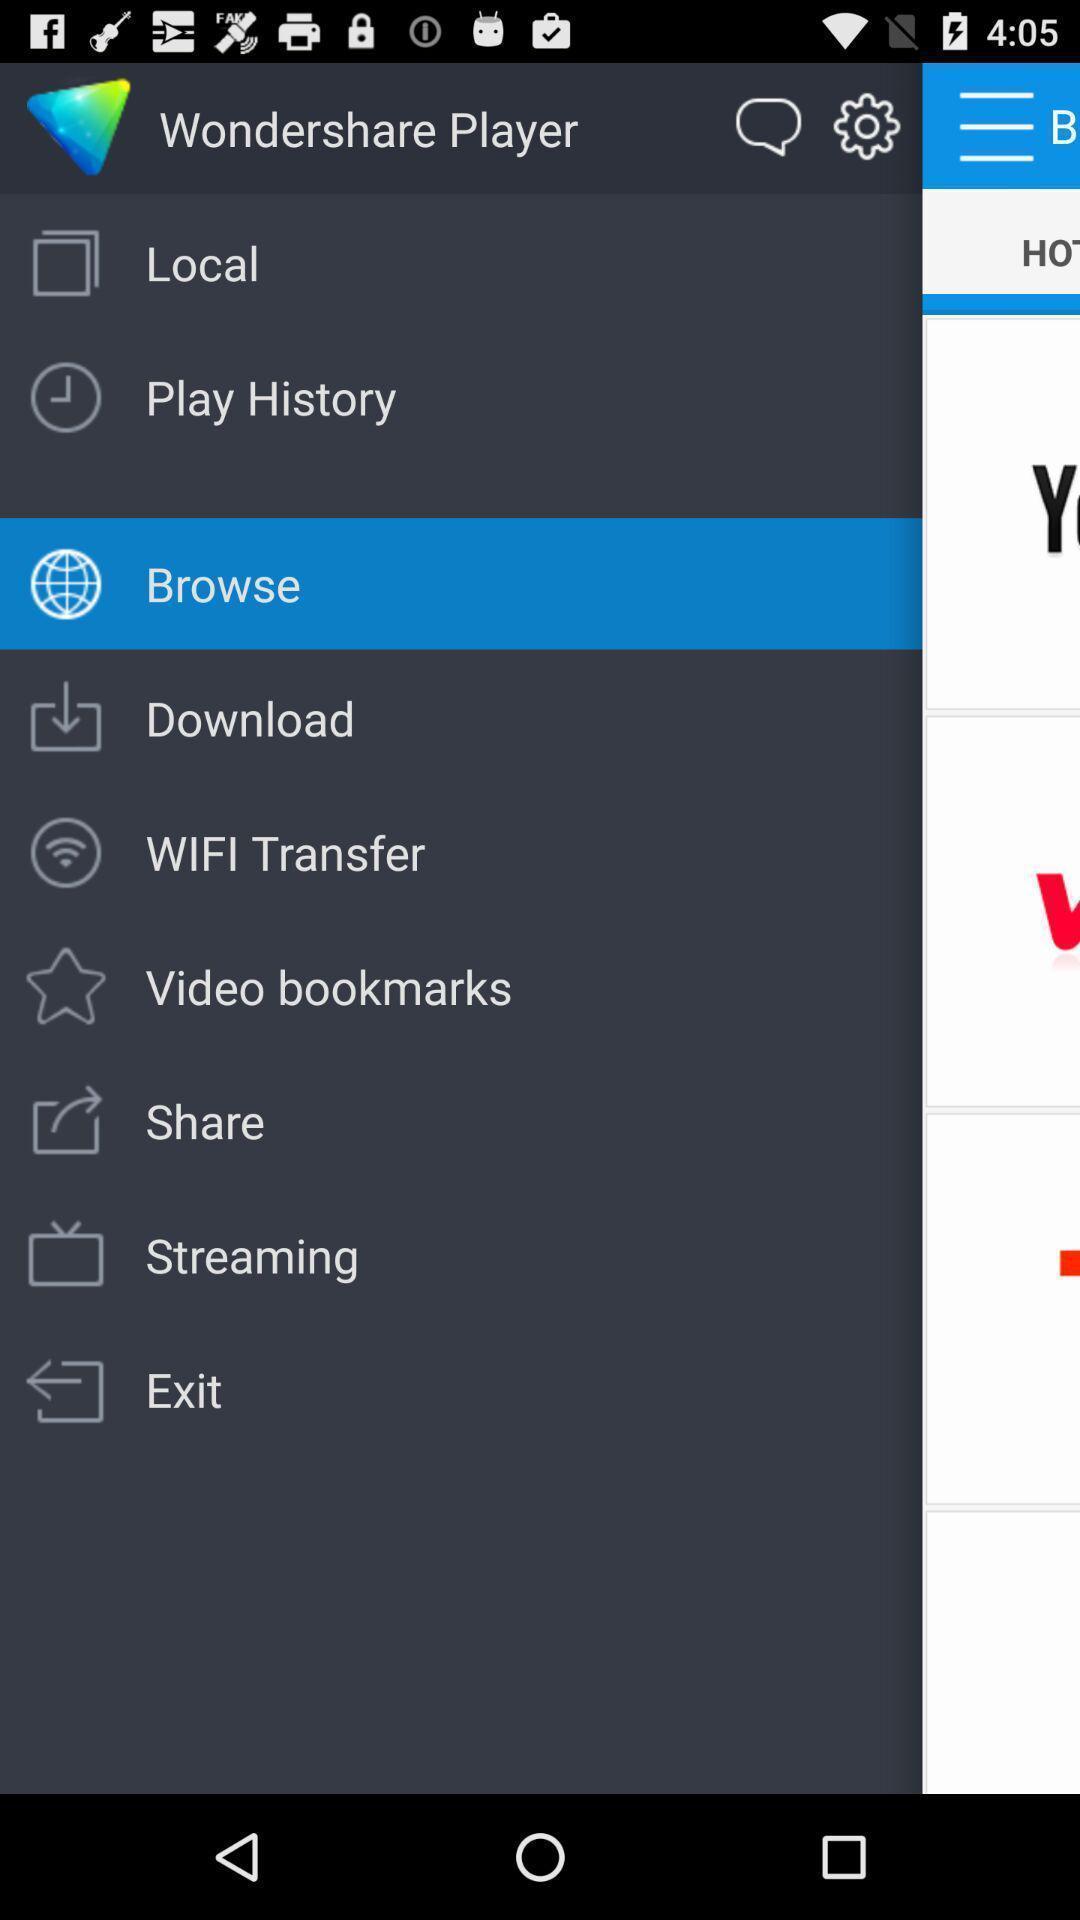Tell me what you see in this picture. Popup slide with list of options. 